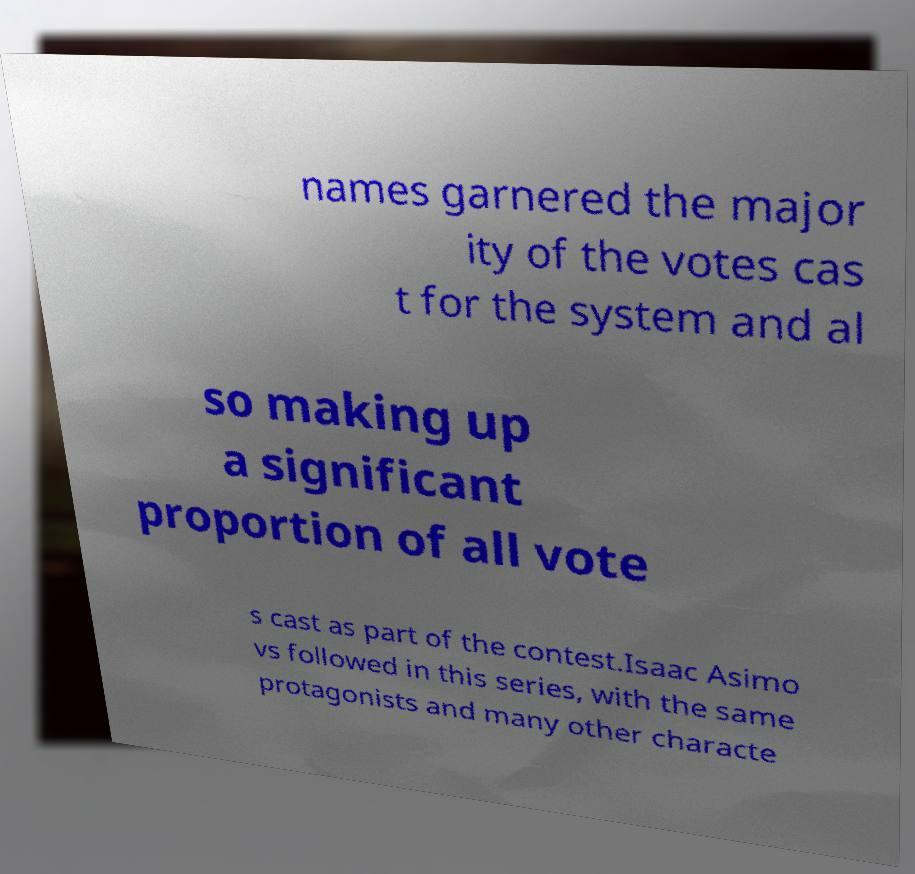Can you accurately transcribe the text from the provided image for me? names garnered the major ity of the votes cas t for the system and al so making up a significant proportion of all vote s cast as part of the contest.Isaac Asimo vs followed in this series, with the same protagonists and many other characte 